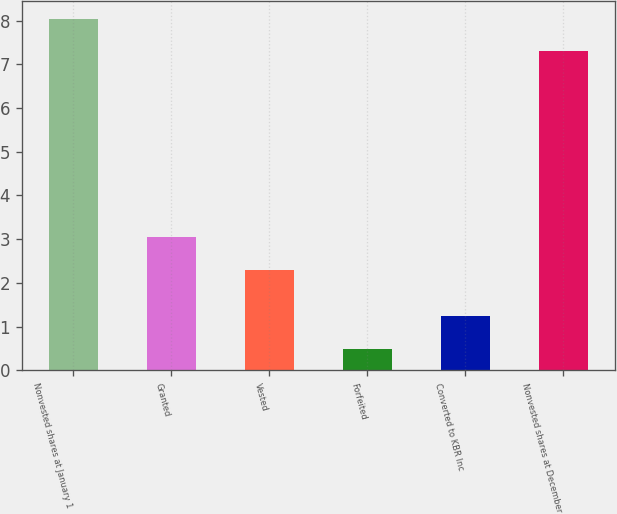Convert chart. <chart><loc_0><loc_0><loc_500><loc_500><bar_chart><fcel>Nonvested shares at January 1<fcel>Granted<fcel>Vested<fcel>Forfeited<fcel>Converted to KBR Inc<fcel>Nonvested shares at December<nl><fcel>8.04<fcel>3.04<fcel>2.3<fcel>0.5<fcel>1.24<fcel>7.3<nl></chart> 